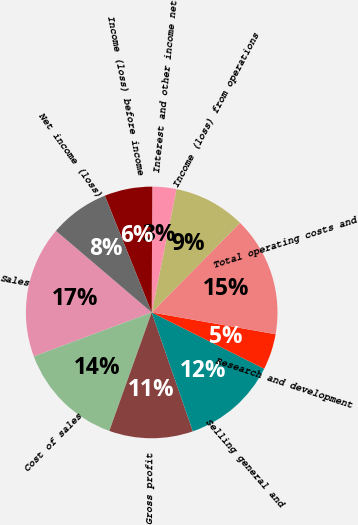Convert chart to OTSL. <chart><loc_0><loc_0><loc_500><loc_500><pie_chart><fcel>Sales<fcel>Cost of sales<fcel>Gross profit<fcel>Selling general and<fcel>Research and development<fcel>Total operating costs and<fcel>Income (loss) from operations<fcel>Interest and other income net<fcel>Income (loss) before income<fcel>Net income (loss)<nl><fcel>16.92%<fcel>13.85%<fcel>10.77%<fcel>12.31%<fcel>4.62%<fcel>15.38%<fcel>9.23%<fcel>3.08%<fcel>6.15%<fcel>7.69%<nl></chart> 